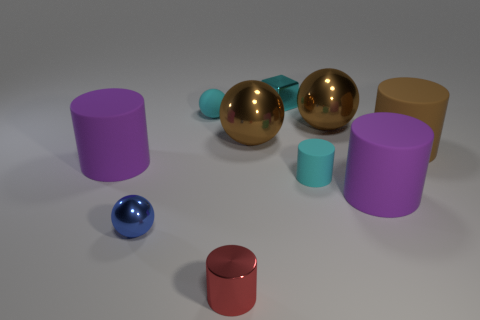Is the color of the tiny matte ball the same as the tiny rubber cylinder?
Your response must be concise. Yes. How many cyan matte objects are the same size as the cube?
Your response must be concise. 2. Are there more cyan objects on the right side of the blue metallic thing than blue objects behind the small cyan ball?
Keep it short and to the point. Yes. What color is the large cylinder behind the rubber cylinder left of the small red metal object?
Your response must be concise. Brown. Is the material of the tiny red cylinder the same as the cyan sphere?
Provide a short and direct response. No. Are there any matte objects that have the same shape as the red metallic object?
Make the answer very short. Yes. There is a metal object that is behind the cyan matte sphere; is it the same color as the rubber sphere?
Your answer should be very brief. Yes. There is a cyan object that is left of the red metallic cylinder; is its size the same as the cylinder that is in front of the blue shiny thing?
Your response must be concise. Yes. What is the size of the brown cylinder that is the same material as the small cyan cylinder?
Offer a very short reply. Large. How many matte objects are in front of the tiny rubber cylinder and behind the brown cylinder?
Offer a terse response. 0. 